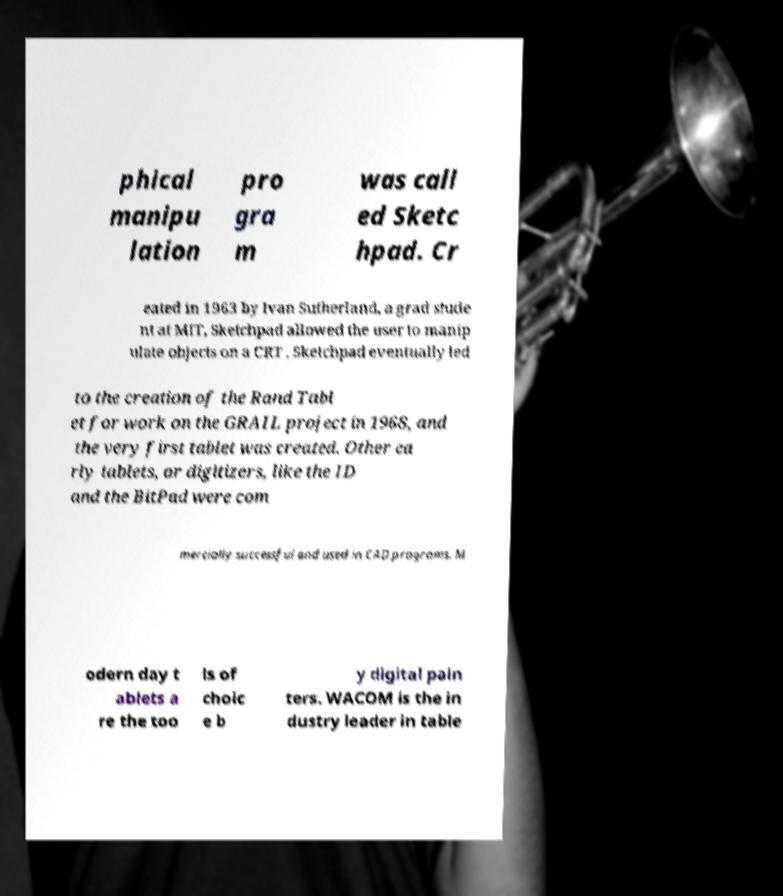Please read and relay the text visible in this image. What does it say? phical manipu lation pro gra m was call ed Sketc hpad. Cr eated in 1963 by Ivan Sutherland, a grad stude nt at MIT, Sketchpad allowed the user to manip ulate objects on a CRT . Sketchpad eventually led to the creation of the Rand Tabl et for work on the GRAIL project in 1968, and the very first tablet was created. Other ea rly tablets, or digitizers, like the ID and the BitPad were com mercially successful and used in CAD programs. M odern day t ablets a re the too ls of choic e b y digital pain ters. WACOM is the in dustry leader in table 